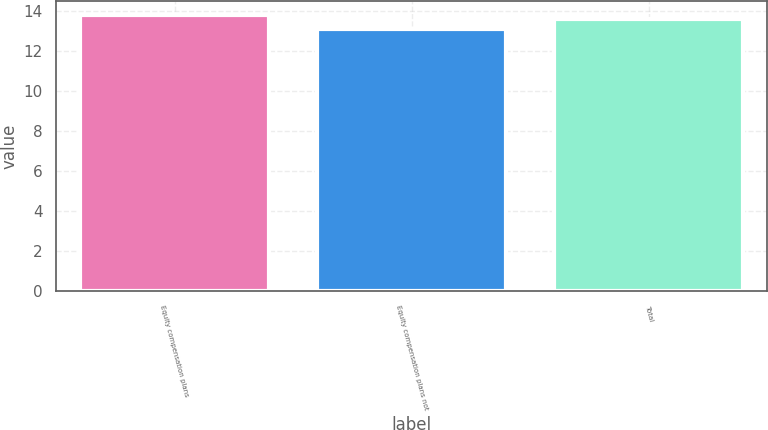<chart> <loc_0><loc_0><loc_500><loc_500><bar_chart><fcel>Equity compensation plans<fcel>Equity compensation plans not<fcel>Total<nl><fcel>13.8<fcel>13.09<fcel>13.59<nl></chart> 